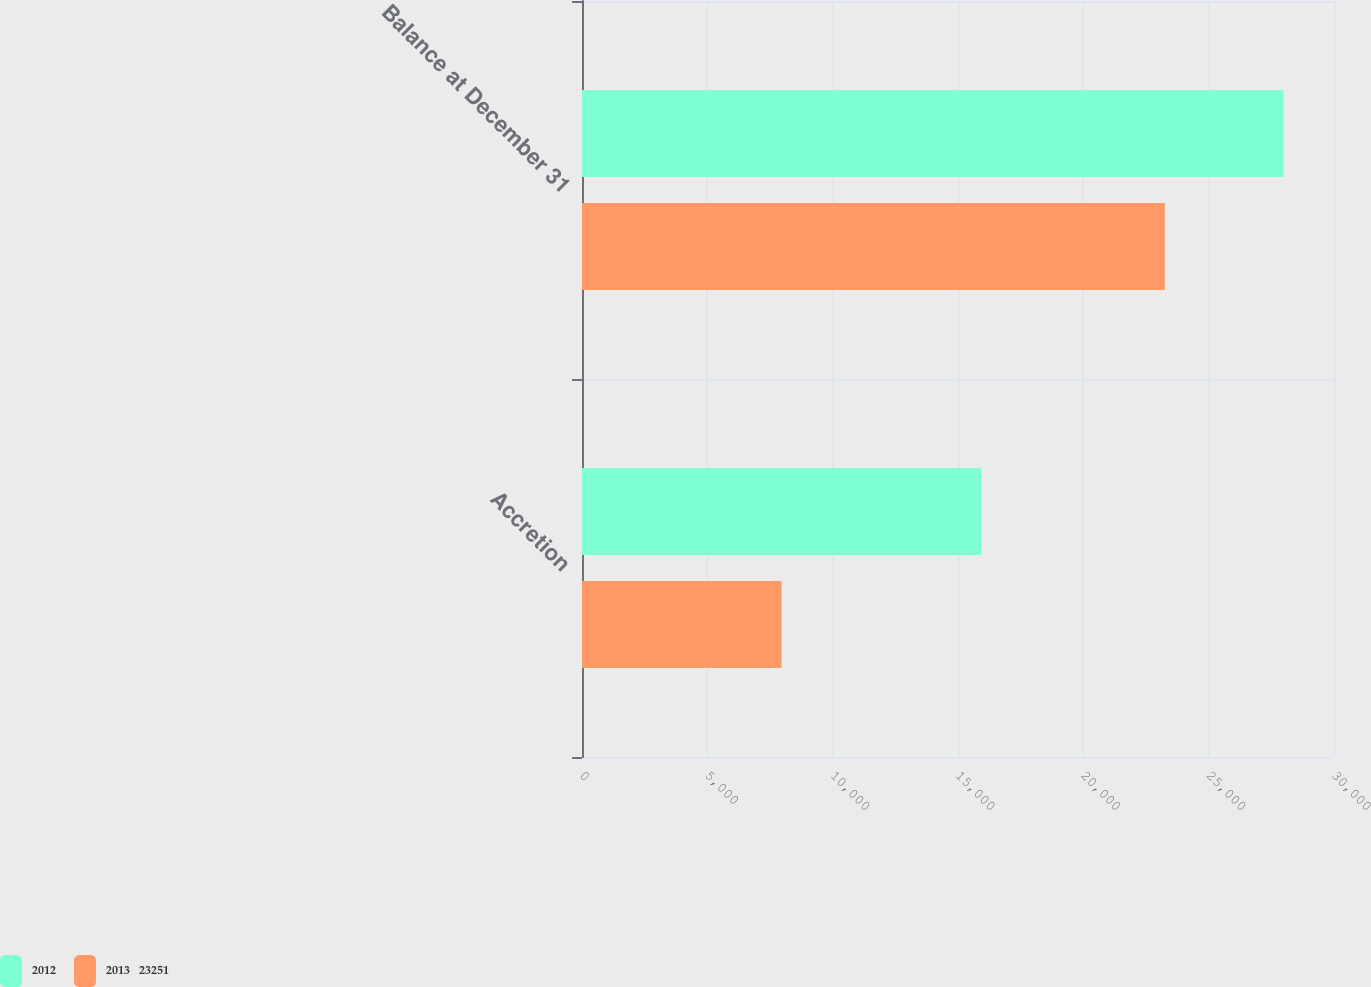Convert chart. <chart><loc_0><loc_0><loc_500><loc_500><stacked_bar_chart><ecel><fcel>Accretion<fcel>Balance at December 31<nl><fcel>2012<fcel>15931<fcel>27995<nl><fcel>2013   23251<fcel>7960<fcel>23251<nl></chart> 